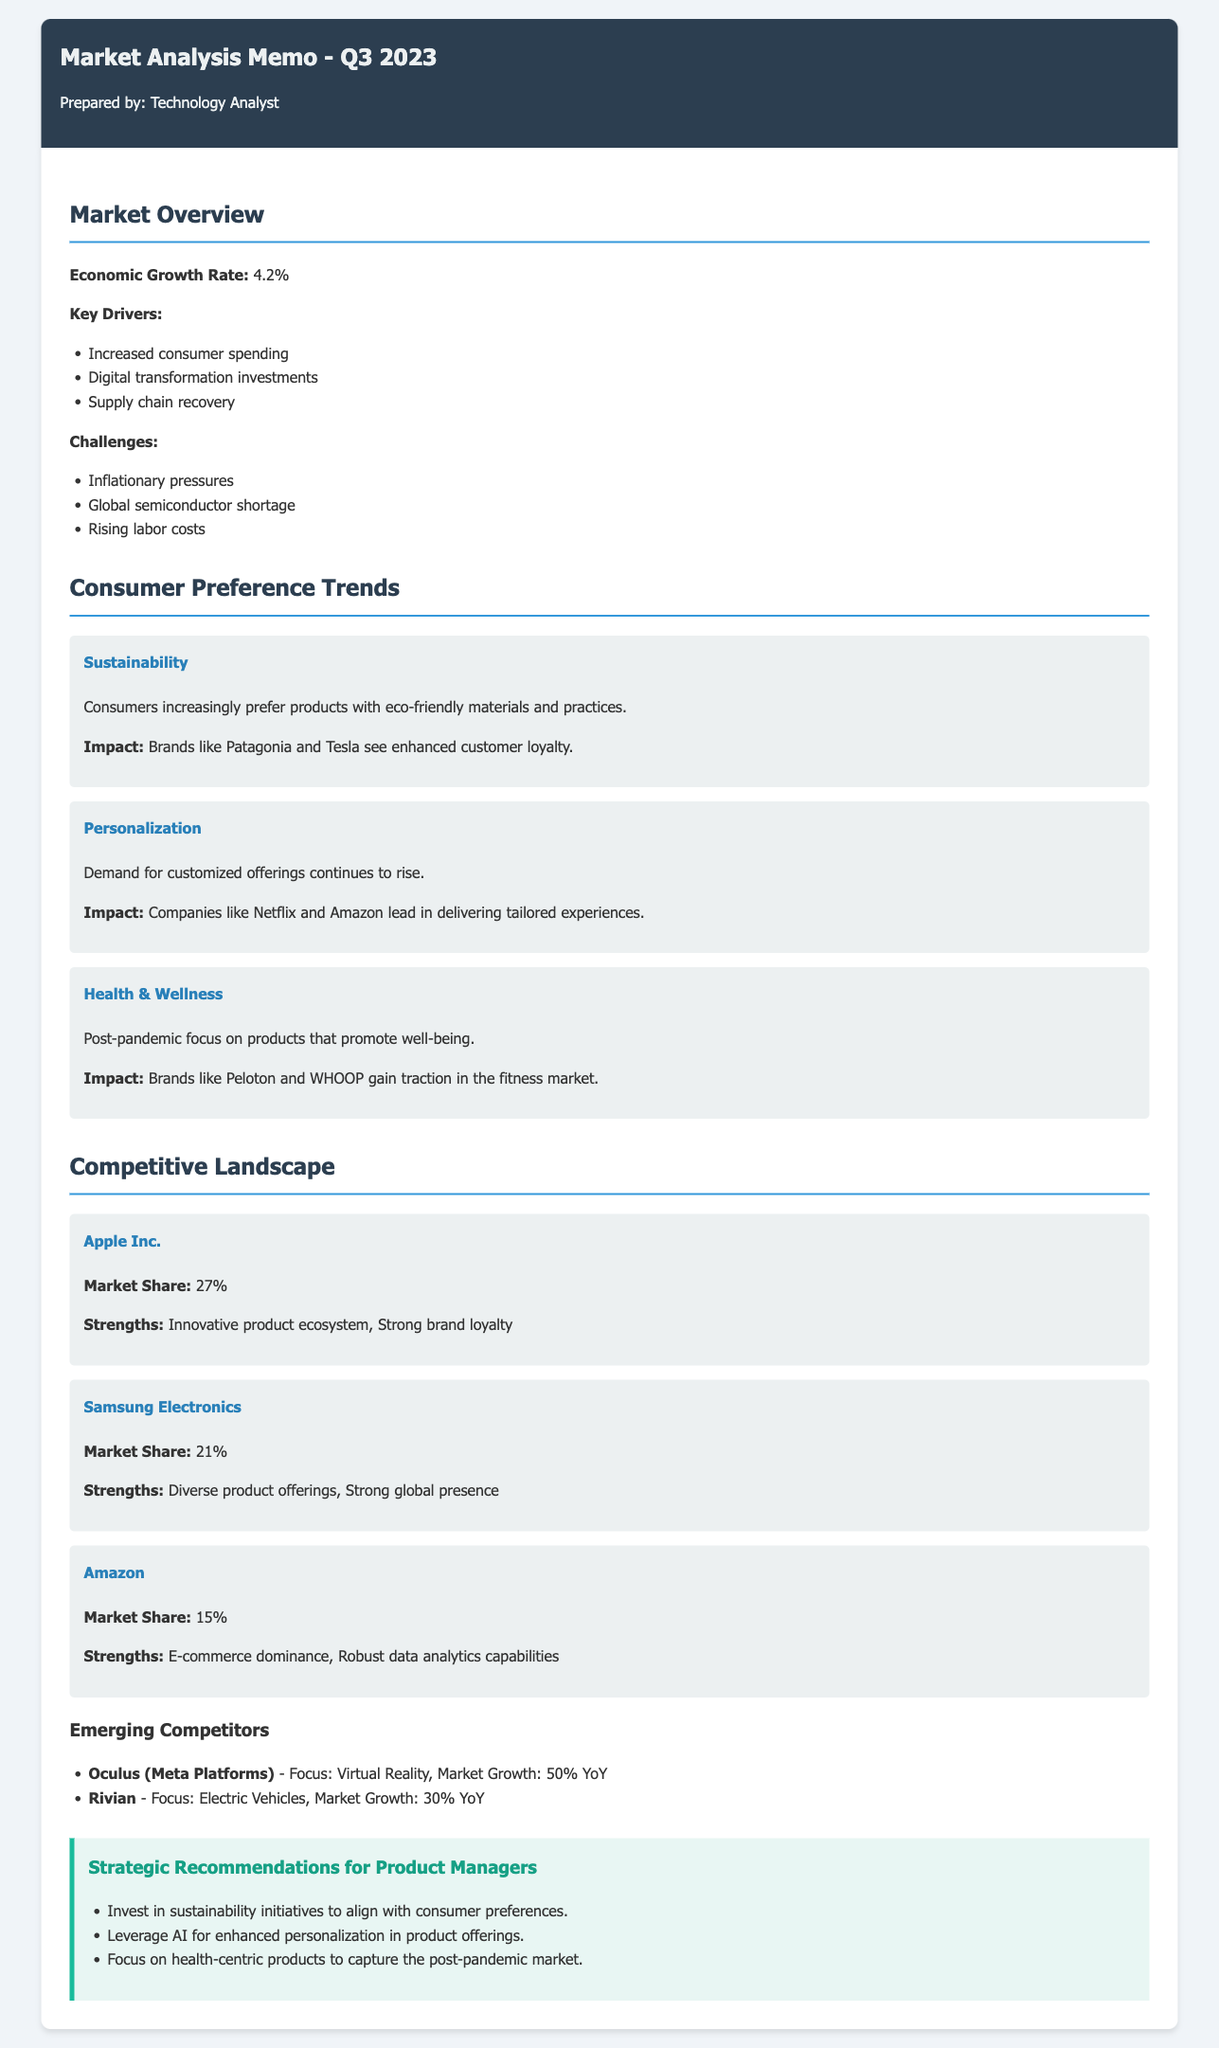What is the economic growth rate mentioned? The economic growth rate is explicitly stated in the document as 4.2%.
Answer: 4.2% Which company has a market share of 27%? The document lists Apple Inc. with a market share of 27%.
Answer: Apple Inc What is one key driver of market growth? The document highlights "Increased consumer spending" as one of the key drivers.
Answer: Increased consumer spending What trend is related to eco-friendly products? The document identifies "Sustainability" as the trend relating to eco-friendly products.
Answer: Sustainability Which company is noted for its e-commerce dominance? Amazon is mentioned as having robust e-commerce capabilities.
Answer: Amazon What percentage did Oculus (Meta Platforms) grow year-over-year? The document states that Oculus experienced a market growth of 50% YoY.
Answer: 50% What is one recommendation for product managers? The document includes "Invest in sustainability initiatives" as a key recommendation.
Answer: Invest in sustainability initiatives Which competitor has a market share of 21%? Samsung Electronics is listed in the document with a market share of 21%.
Answer: Samsung Electronics How many consumer preference trends are discussed? The document lists three consumer preference trends.
Answer: Three 